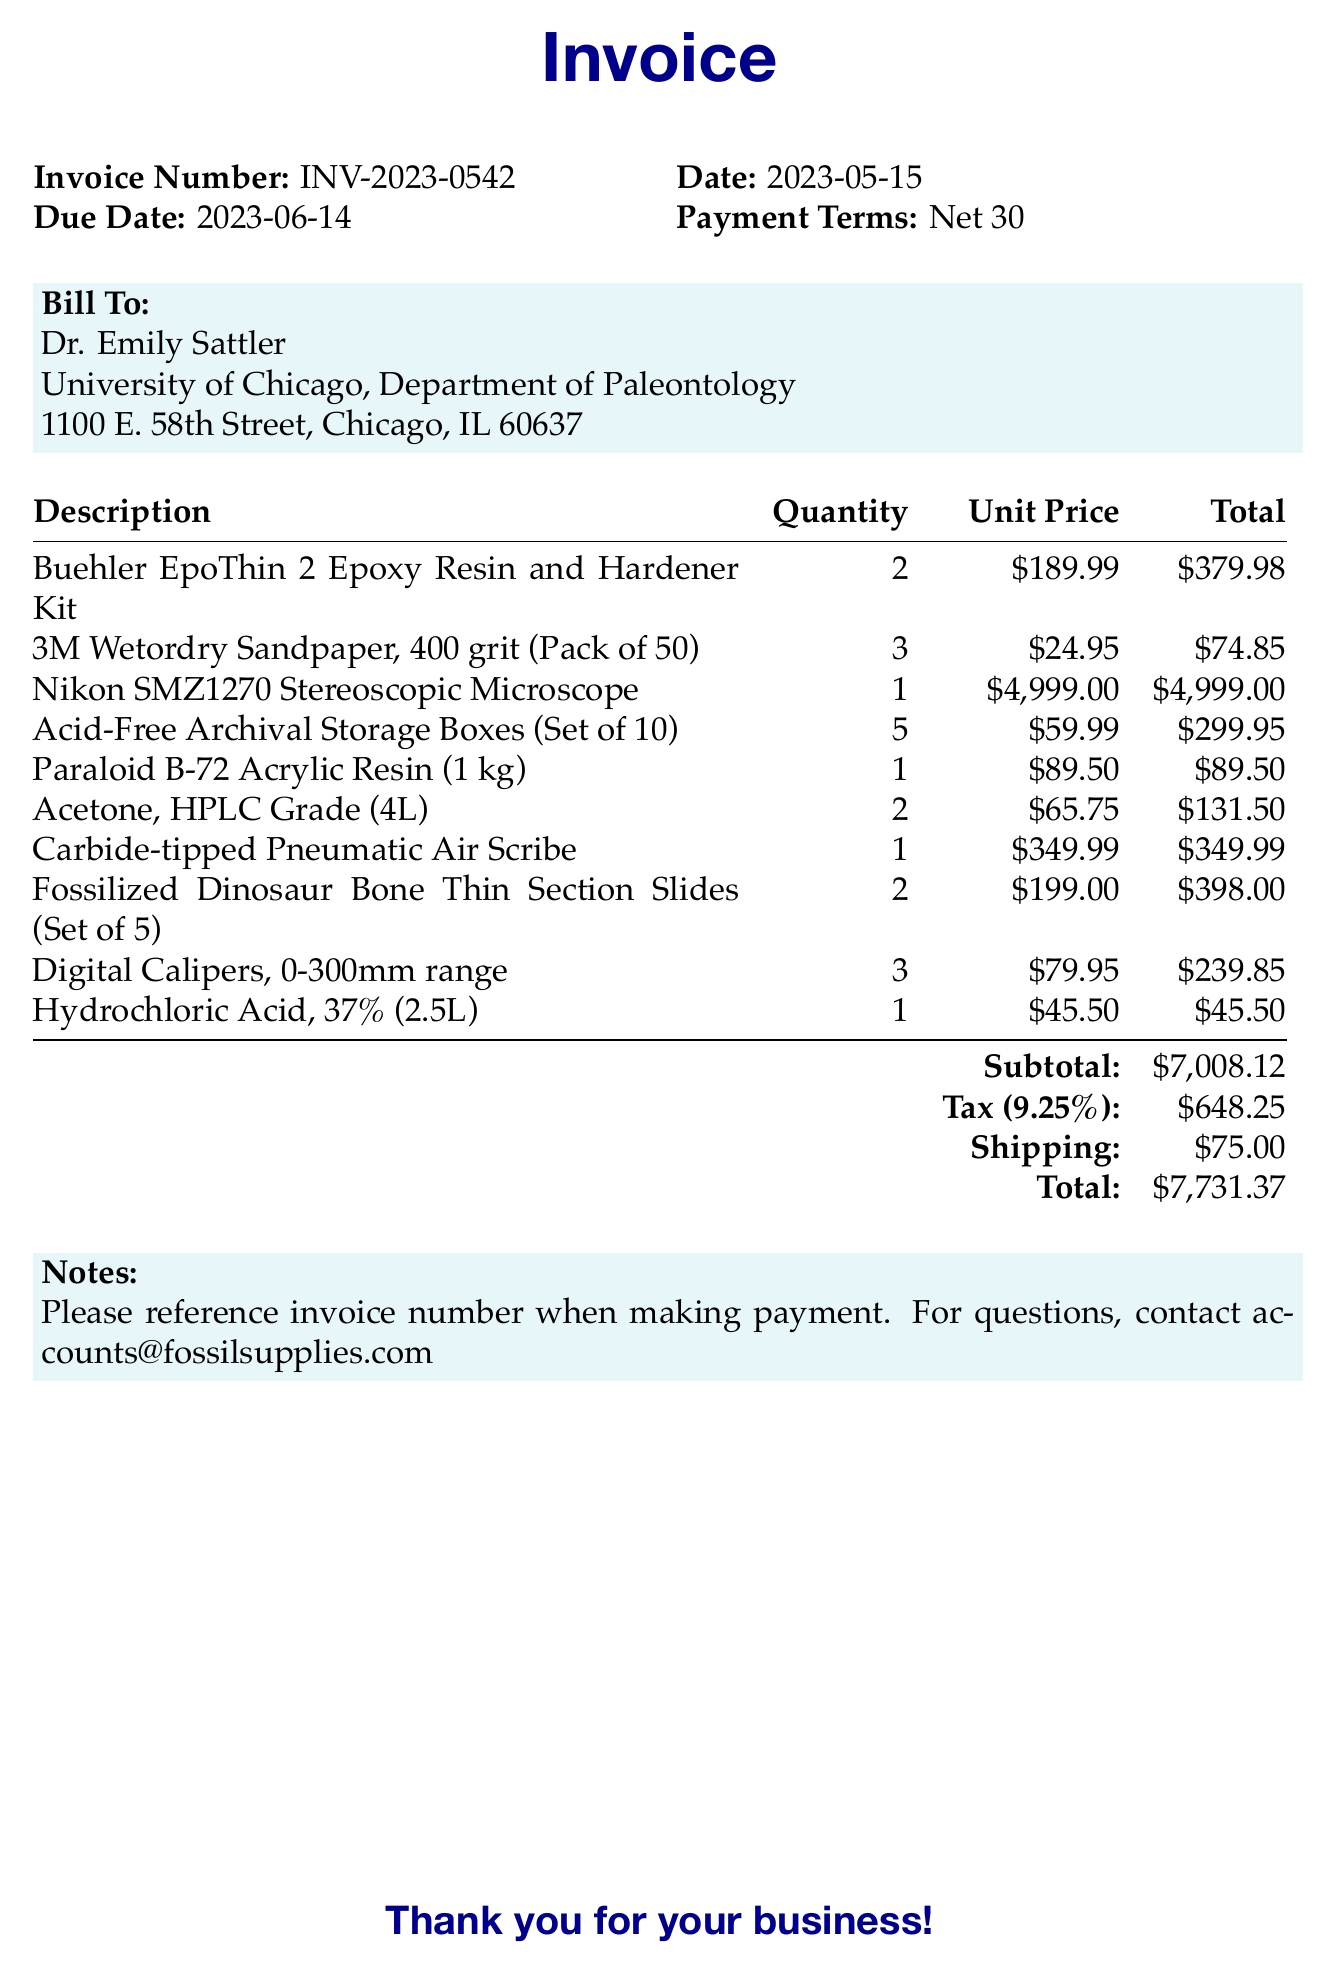What is the invoice number? The invoice number is stated clearly in the document under invoice details.
Answer: INV-2023-0542 What is the total amount due? The total amount due is mentioned in the document at the end of the itemized list.
Answer: $7,731.37 Who is the bill to? The bill to section includes the name and institution of the individual responsible for payment.
Answer: Dr. Emily Sattler What is the tax rate applied? The tax rate can be found next to the tax amount in the summary section of the invoice.
Answer: 9.25% How many Digital Calipers were ordered? The quantity of Digital Calipers is listed in the itemized section of the invoice.
Answer: 3 What is the payment term for this invoice? The payment terms are explicitly noted in the document under invoice details.
Answer: Net 30 What items are listed for fossil preparation and analysis? The items include various supplies for fossil preparation and analysis as detailed in the itemized list.
Answer: 10 items How much does the Nikon SMZ1270 Stereoscopic Microscope cost? The price is provided in the itemized list for the specific item.
Answer: $4,999.00 What is the shipping cost? The shipping cost is mentioned in the summary section at the end of the invoice.
Answer: $75.00 